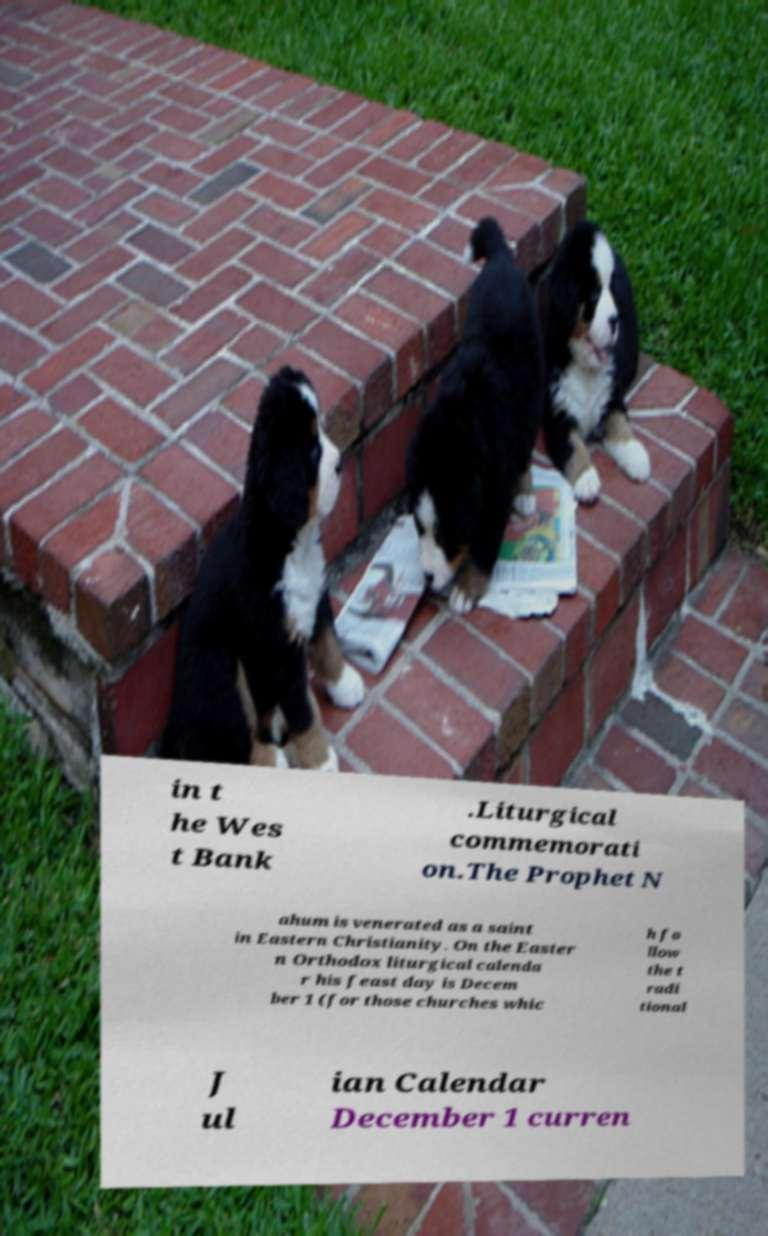I need the written content from this picture converted into text. Can you do that? in t he Wes t Bank .Liturgical commemorati on.The Prophet N ahum is venerated as a saint in Eastern Christianity. On the Easter n Orthodox liturgical calenda r his feast day is Decem ber 1 (for those churches whic h fo llow the t radi tional J ul ian Calendar December 1 curren 